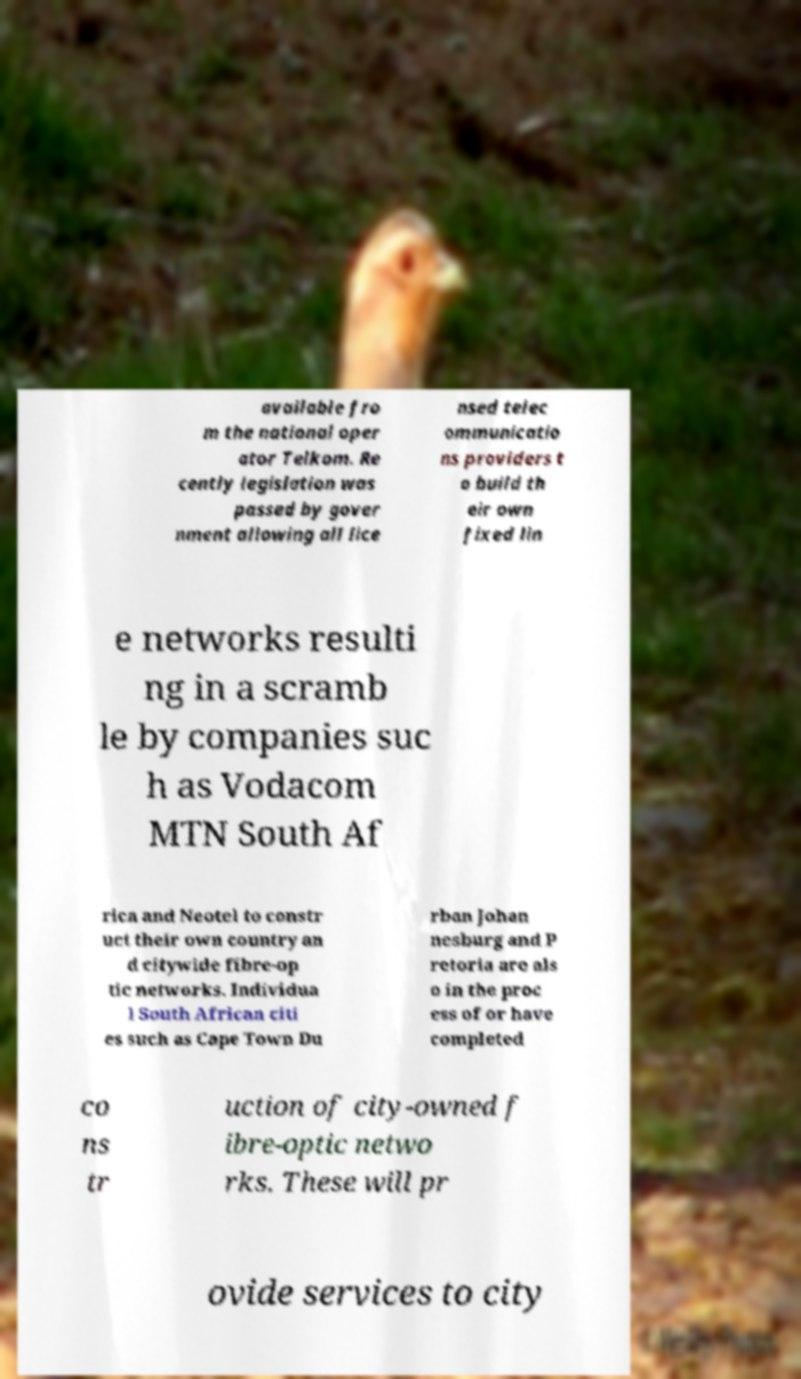I need the written content from this picture converted into text. Can you do that? available fro m the national oper ator Telkom. Re cently legislation was passed by gover nment allowing all lice nsed telec ommunicatio ns providers t o build th eir own fixed lin e networks resulti ng in a scramb le by companies suc h as Vodacom MTN South Af rica and Neotel to constr uct their own country an d citywide fibre-op tic networks. Individua l South African citi es such as Cape Town Du rban Johan nesburg and P retoria are als o in the proc ess of or have completed co ns tr uction of city-owned f ibre-optic netwo rks. These will pr ovide services to city 